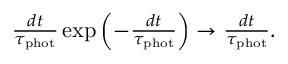<formula> <loc_0><loc_0><loc_500><loc_500>\begin{array} { r } { \frac { d t } { \tau _ { p h o t } } \exp \left ( - \frac { d t } { \tau _ { p h o t } } \right ) \rightarrow \frac { d t } { \tau _ { p h o t } } . } \end{array}</formula> 